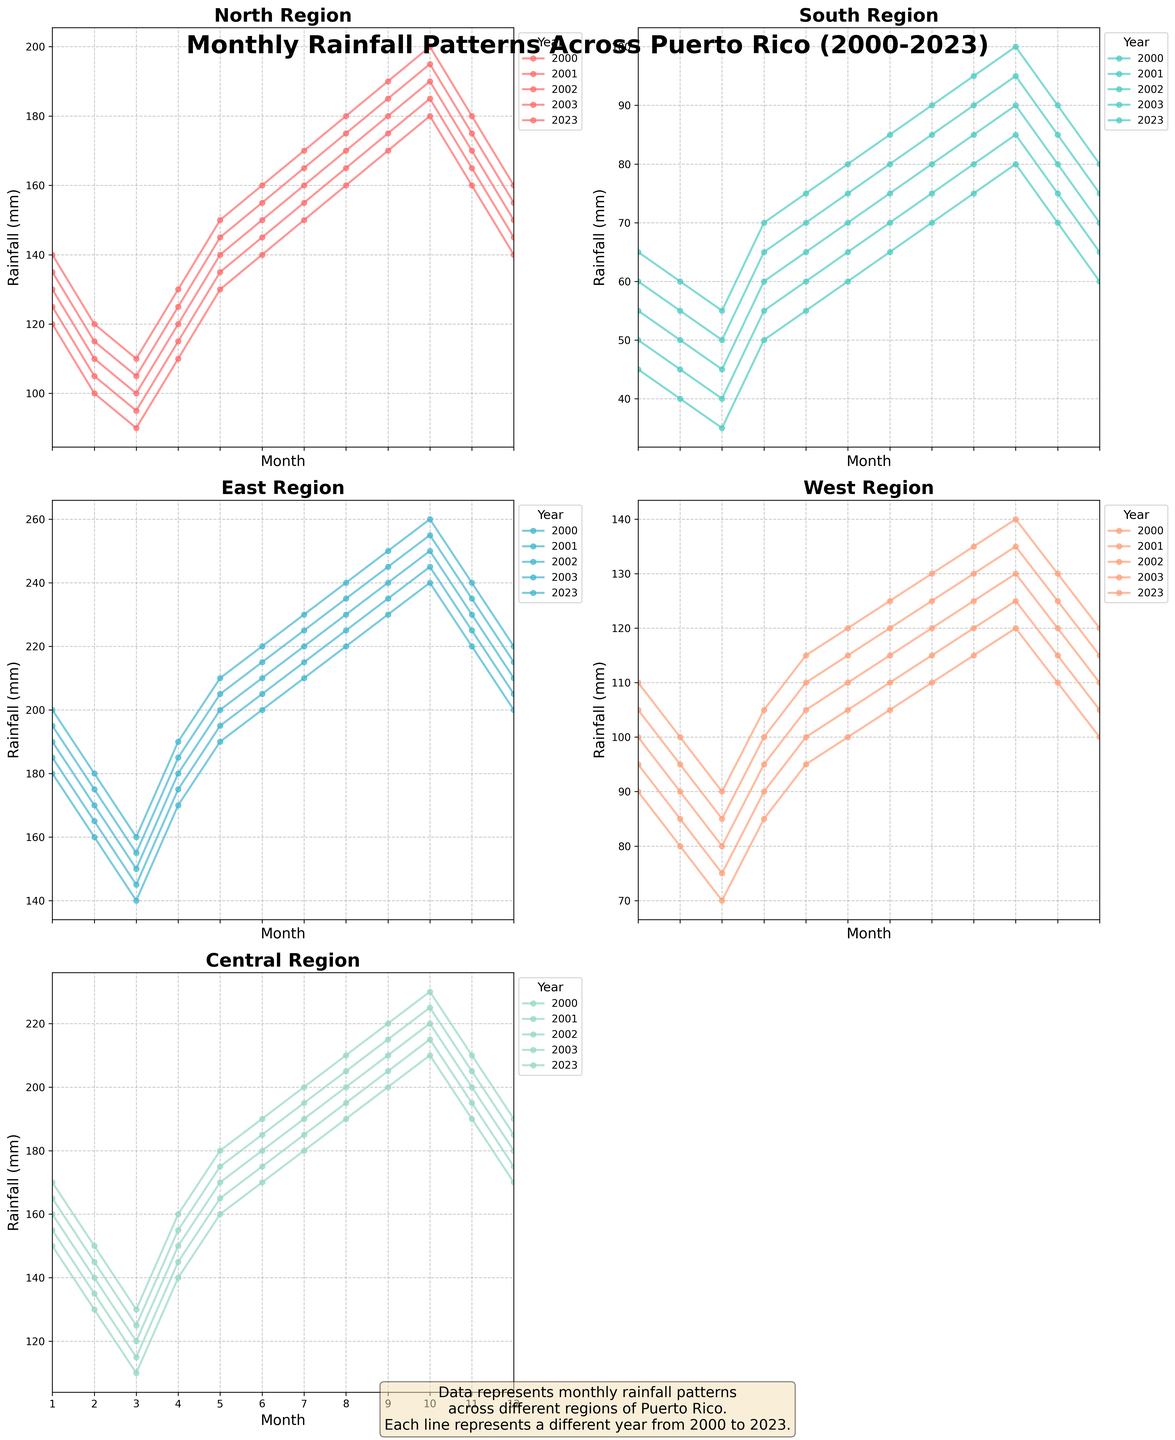Which region experienced the highest rainfall in July 2023? To find the region with the highest rainfall in July 2023, locate July under the 2023 data and compare the values for each region: North (170), South (85), East (230), West (125), Central (200). The East region has the highest rainfall.
Answer: East What is the average rainfall for the North region in the year 2000? First, find the monthly rainfall values for the North region in 2000: [120, 100, 90, 110, 130, 140, 150, 160, 170, 180, 160, 140]. Sum these values (1550) and divide by the number of months (12) to get the average. 1550 / 12 = 129.17.
Answer: 129.17 Compare the rainfall in the Central region between January 2000 and January 2023; which year had higher rainfall? Find the rainfall data for the Central region in January for both years: 2000 (150) and 2023 (170). Comparing these two values, January 2023 had higher rainfall (170 mm) than January 2000 (150 mm).
Answer: 2023 Which region showed the lowest rainfall in May 2001? Check the rainfall values for each region in May 2001: North (135), South (60), East (195), West (100), Central (165). The South region had the lowest rainfall, with only 60 mm.
Answer: South What is the trend in rainfall in the East region from January to December in 2023? Examine the rainfall values for the East region from January (200) to December (220) in 2023 and observe the trend. The values show a general increase from January (200) towards December (220), with a slight decrease in November (240 to 220).
Answer: Increasing In October 2023, how much more rainfall did the North region receive compared to the South region? Find the rainfall values for both regions in October 2023: North (200), South (100). Calculate the difference: 200 - 100 = 100. The North received 100 mm more rainfall.
Answer: 100 What is the combined rainfall for the West and Central regions in December 2002? Find the rainfall values for December 2002: West (110), Central (180). Sum these values: 110 + 180 = 290.
Answer: 290 For the Central region, what is the difference in rainfall between the wettest and driest months in 2003? Identify the highest and lowest rainfall values for the Central region in 2003: Highest in October (225), Lowest in March (125). Find the difference: 225 - 125 = 100.
Answer: 100 Which region had the most variable rainfall in 2002? To find the most variable region, check the range (difference between highest and lowest values) for each region in 2002: North (range 190 - 110 = 80), South (range 90 - 50 = 40), East (range 250 - 150 = 100), West (range 130 - 80 = 50), Central (range 220 - 140 = 80). The East region has the highest variability.
Answer: East 